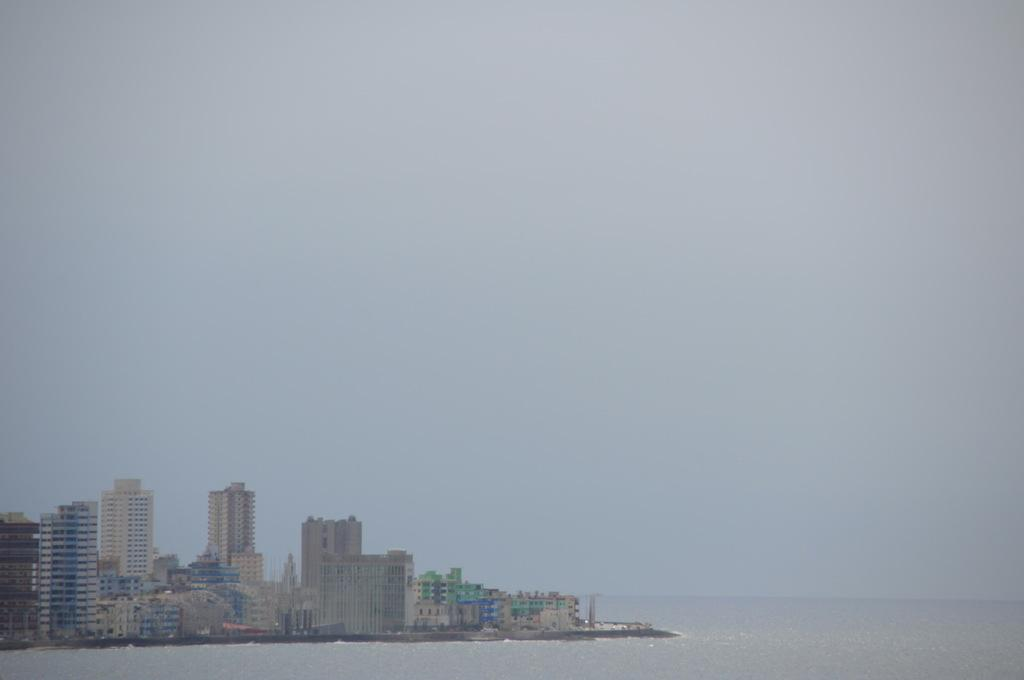What type of structures are present in the image? There is a group of buildings with windows in the image. Where are these buildings located? The buildings are on an island. What can be seen in the background of the image? There is a large water body visible in the image. How would you describe the weather in the image? The sky is cloudy in the image. What type of property does the girl own on the island in the image? There is no girl present in the image, and therefore no information about her property ownership. 